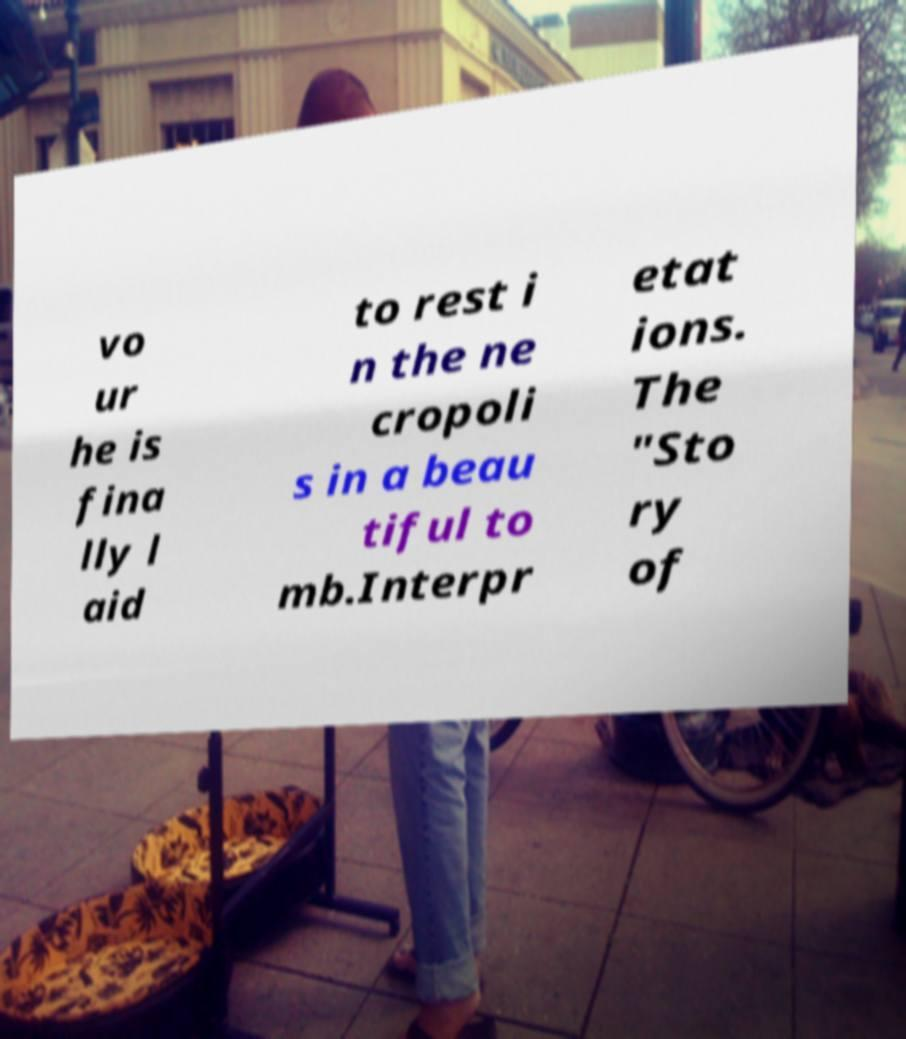Could you extract and type out the text from this image? vo ur he is fina lly l aid to rest i n the ne cropoli s in a beau tiful to mb.Interpr etat ions. The "Sto ry of 